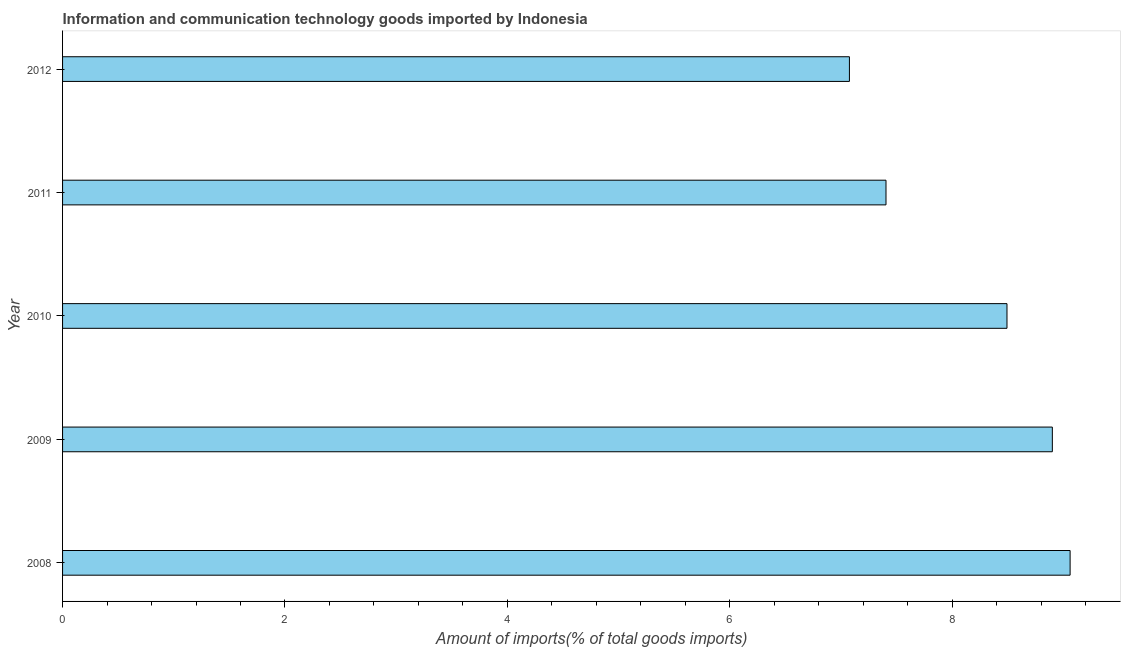Does the graph contain any zero values?
Provide a succinct answer. No. Does the graph contain grids?
Offer a terse response. No. What is the title of the graph?
Provide a succinct answer. Information and communication technology goods imported by Indonesia. What is the label or title of the X-axis?
Your answer should be very brief. Amount of imports(% of total goods imports). What is the amount of ict goods imports in 2011?
Provide a succinct answer. 7.41. Across all years, what is the maximum amount of ict goods imports?
Provide a succinct answer. 9.06. Across all years, what is the minimum amount of ict goods imports?
Ensure brevity in your answer.  7.08. What is the sum of the amount of ict goods imports?
Provide a succinct answer. 40.94. What is the difference between the amount of ict goods imports in 2008 and 2011?
Give a very brief answer. 1.66. What is the average amount of ict goods imports per year?
Keep it short and to the point. 8.19. What is the median amount of ict goods imports?
Your response must be concise. 8.49. In how many years, is the amount of ict goods imports greater than 8 %?
Provide a short and direct response. 3. Do a majority of the years between 2009 and 2012 (inclusive) have amount of ict goods imports greater than 7.6 %?
Your answer should be very brief. No. What is the ratio of the amount of ict goods imports in 2009 to that in 2011?
Offer a terse response. 1.2. Is the difference between the amount of ict goods imports in 2009 and 2012 greater than the difference between any two years?
Provide a succinct answer. No. What is the difference between the highest and the second highest amount of ict goods imports?
Give a very brief answer. 0.16. What is the difference between the highest and the lowest amount of ict goods imports?
Make the answer very short. 1.98. In how many years, is the amount of ict goods imports greater than the average amount of ict goods imports taken over all years?
Provide a succinct answer. 3. How many bars are there?
Your response must be concise. 5. Are all the bars in the graph horizontal?
Make the answer very short. Yes. What is the difference between two consecutive major ticks on the X-axis?
Your answer should be compact. 2. What is the Amount of imports(% of total goods imports) of 2008?
Keep it short and to the point. 9.06. What is the Amount of imports(% of total goods imports) in 2009?
Give a very brief answer. 8.9. What is the Amount of imports(% of total goods imports) of 2010?
Offer a terse response. 8.49. What is the Amount of imports(% of total goods imports) of 2011?
Provide a succinct answer. 7.41. What is the Amount of imports(% of total goods imports) in 2012?
Ensure brevity in your answer.  7.08. What is the difference between the Amount of imports(% of total goods imports) in 2008 and 2009?
Your answer should be compact. 0.16. What is the difference between the Amount of imports(% of total goods imports) in 2008 and 2010?
Keep it short and to the point. 0.57. What is the difference between the Amount of imports(% of total goods imports) in 2008 and 2011?
Ensure brevity in your answer.  1.66. What is the difference between the Amount of imports(% of total goods imports) in 2008 and 2012?
Provide a succinct answer. 1.98. What is the difference between the Amount of imports(% of total goods imports) in 2009 and 2010?
Provide a succinct answer. 0.41. What is the difference between the Amount of imports(% of total goods imports) in 2009 and 2011?
Your answer should be very brief. 1.5. What is the difference between the Amount of imports(% of total goods imports) in 2009 and 2012?
Provide a short and direct response. 1.82. What is the difference between the Amount of imports(% of total goods imports) in 2010 and 2011?
Offer a very short reply. 1.09. What is the difference between the Amount of imports(% of total goods imports) in 2010 and 2012?
Offer a terse response. 1.42. What is the difference between the Amount of imports(% of total goods imports) in 2011 and 2012?
Keep it short and to the point. 0.33. What is the ratio of the Amount of imports(% of total goods imports) in 2008 to that in 2009?
Give a very brief answer. 1.02. What is the ratio of the Amount of imports(% of total goods imports) in 2008 to that in 2010?
Offer a very short reply. 1.07. What is the ratio of the Amount of imports(% of total goods imports) in 2008 to that in 2011?
Make the answer very short. 1.22. What is the ratio of the Amount of imports(% of total goods imports) in 2008 to that in 2012?
Your answer should be very brief. 1.28. What is the ratio of the Amount of imports(% of total goods imports) in 2009 to that in 2010?
Your response must be concise. 1.05. What is the ratio of the Amount of imports(% of total goods imports) in 2009 to that in 2011?
Provide a short and direct response. 1.2. What is the ratio of the Amount of imports(% of total goods imports) in 2009 to that in 2012?
Offer a terse response. 1.26. What is the ratio of the Amount of imports(% of total goods imports) in 2010 to that in 2011?
Provide a succinct answer. 1.15. What is the ratio of the Amount of imports(% of total goods imports) in 2010 to that in 2012?
Offer a terse response. 1.2. What is the ratio of the Amount of imports(% of total goods imports) in 2011 to that in 2012?
Provide a short and direct response. 1.05. 